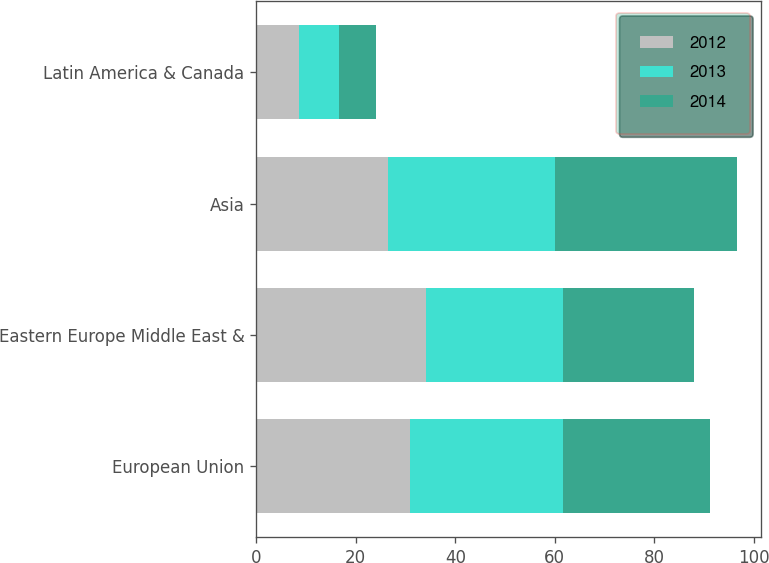Convert chart to OTSL. <chart><loc_0><loc_0><loc_500><loc_500><stacked_bar_chart><ecel><fcel>European Union<fcel>Eastern Europe Middle East &<fcel>Asia<fcel>Latin America & Canada<nl><fcel>2012<fcel>30.9<fcel>34.2<fcel>26.4<fcel>8.5<nl><fcel>2013<fcel>30.8<fcel>27.4<fcel>33.6<fcel>8.2<nl><fcel>2014<fcel>29.6<fcel>26.3<fcel>36.7<fcel>7.4<nl></chart> 